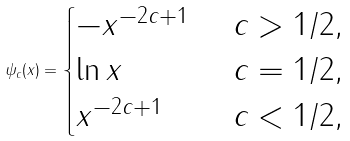<formula> <loc_0><loc_0><loc_500><loc_500>\psi _ { c } ( x ) = \begin{cases} - x ^ { - 2 c + 1 } & \ c > 1 / 2 , \\ \ln x & \ c = 1 / 2 , \\ x ^ { - 2 c + 1 } & \ c < 1 / 2 , \end{cases}</formula> 